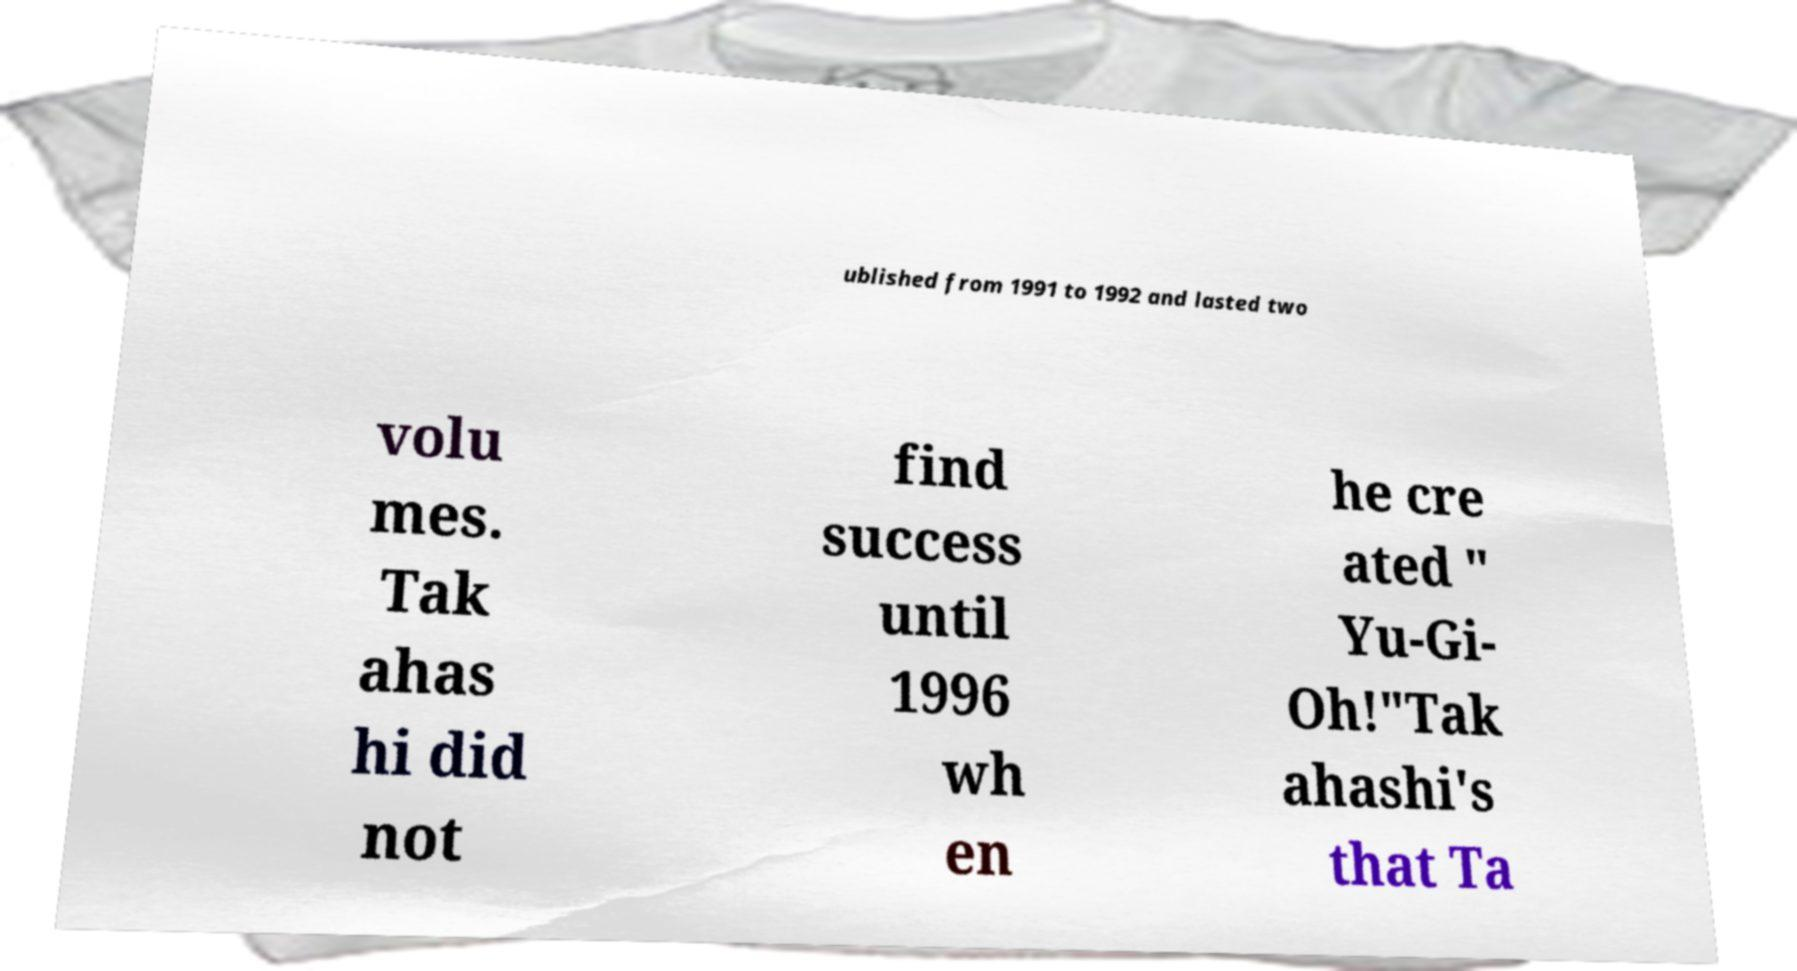Please read and relay the text visible in this image. What does it say? ublished from 1991 to 1992 and lasted two volu mes. Tak ahas hi did not find success until 1996 wh en he cre ated " Yu-Gi- Oh!"Tak ahashi's that Ta 